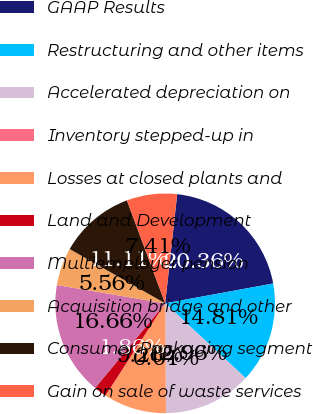Convert chart to OTSL. <chart><loc_0><loc_0><loc_500><loc_500><pie_chart><fcel>GAAP Results<fcel>Restructuring and other items<fcel>Accelerated depreciation on<fcel>Inventory stepped-up in<fcel>Losses at closed plants and<fcel>Land and Development<fcel>Multiemployer pension<fcel>Acquisition bridge and other<fcel>Consumer Packaging segment<fcel>Gain on sale of waste services<nl><fcel>20.36%<fcel>14.81%<fcel>12.96%<fcel>0.01%<fcel>9.26%<fcel>1.86%<fcel>16.66%<fcel>5.56%<fcel>11.11%<fcel>7.41%<nl></chart> 